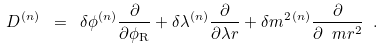Convert formula to latex. <formula><loc_0><loc_0><loc_500><loc_500>D ^ { ( n ) } \ = \ \delta \phi ^ { ( n ) } \frac { \partial } { \partial \phi _ { \mathrm R } } + \delta \lambda ^ { ( n ) } \frac { \partial } { \partial \lambda r } + \delta m ^ { 2 \, ( n ) } \frac { \partial } { \partial \ m r ^ { 2 } } \ .</formula> 